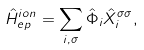<formula> <loc_0><loc_0><loc_500><loc_500>\hat { H } _ { e p } ^ { i o n } = \sum _ { i , \sigma } \hat { \Phi } _ { i } \hat { X } _ { i } ^ { \sigma \sigma } ,</formula> 